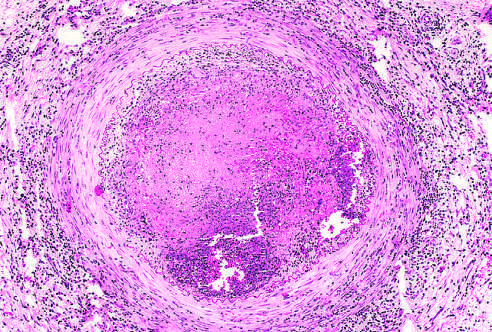s low-power view infiltrated with leukocytes?
Answer the question using a single word or phrase. No 